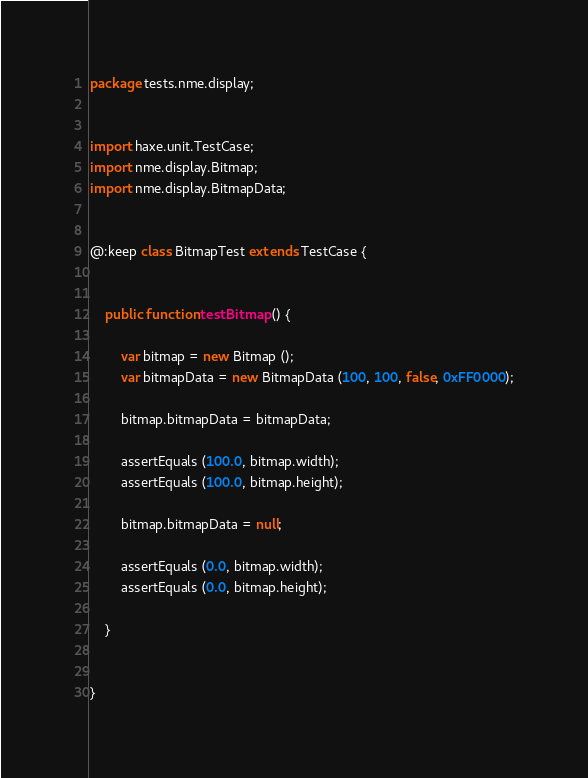Convert code to text. <code><loc_0><loc_0><loc_500><loc_500><_Haxe_>package tests.nme.display;


import haxe.unit.TestCase;
import nme.display.Bitmap;
import nme.display.BitmapData;


@:keep class BitmapTest extends TestCase {
	
	
	public function testBitmap () {
		
		var bitmap = new Bitmap ();
		var bitmapData = new BitmapData (100, 100, false, 0xFF0000);
		
		bitmap.bitmapData = bitmapData;
		
		assertEquals (100.0, bitmap.width);
		assertEquals (100.0, bitmap.height);
		
		bitmap.bitmapData = null;
		
		assertEquals (0.0, bitmap.width);
		assertEquals (0.0, bitmap.height);
		
	}
	
	
}</code> 